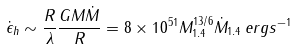Convert formula to latex. <formula><loc_0><loc_0><loc_500><loc_500>\dot { \epsilon } _ { h } \sim \frac { R } { \lambda } \frac { G M \dot { M } } { R } = 8 \times 1 0 ^ { 5 1 } M _ { 1 . 4 } ^ { 1 3 / 6 } \dot { M } _ { 1 . 4 } \, e r g s ^ { - 1 }</formula> 